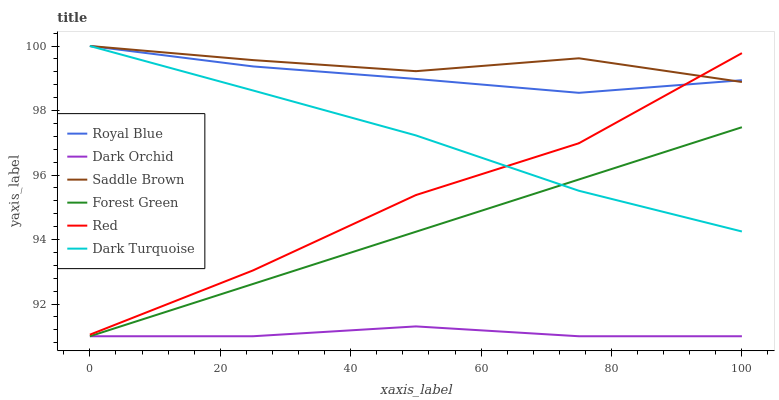Does Dark Orchid have the minimum area under the curve?
Answer yes or no. Yes. Does Saddle Brown have the maximum area under the curve?
Answer yes or no. Yes. Does Royal Blue have the minimum area under the curve?
Answer yes or no. No. Does Royal Blue have the maximum area under the curve?
Answer yes or no. No. Is Forest Green the smoothest?
Answer yes or no. Yes. Is Red the roughest?
Answer yes or no. Yes. Is Dark Orchid the smoothest?
Answer yes or no. No. Is Dark Orchid the roughest?
Answer yes or no. No. Does Dark Orchid have the lowest value?
Answer yes or no. Yes. Does Royal Blue have the lowest value?
Answer yes or no. No. Does Saddle Brown have the highest value?
Answer yes or no. Yes. Does Dark Orchid have the highest value?
Answer yes or no. No. Is Forest Green less than Saddle Brown?
Answer yes or no. Yes. Is Saddle Brown greater than Forest Green?
Answer yes or no. Yes. Does Royal Blue intersect Red?
Answer yes or no. Yes. Is Royal Blue less than Red?
Answer yes or no. No. Is Royal Blue greater than Red?
Answer yes or no. No. Does Forest Green intersect Saddle Brown?
Answer yes or no. No. 